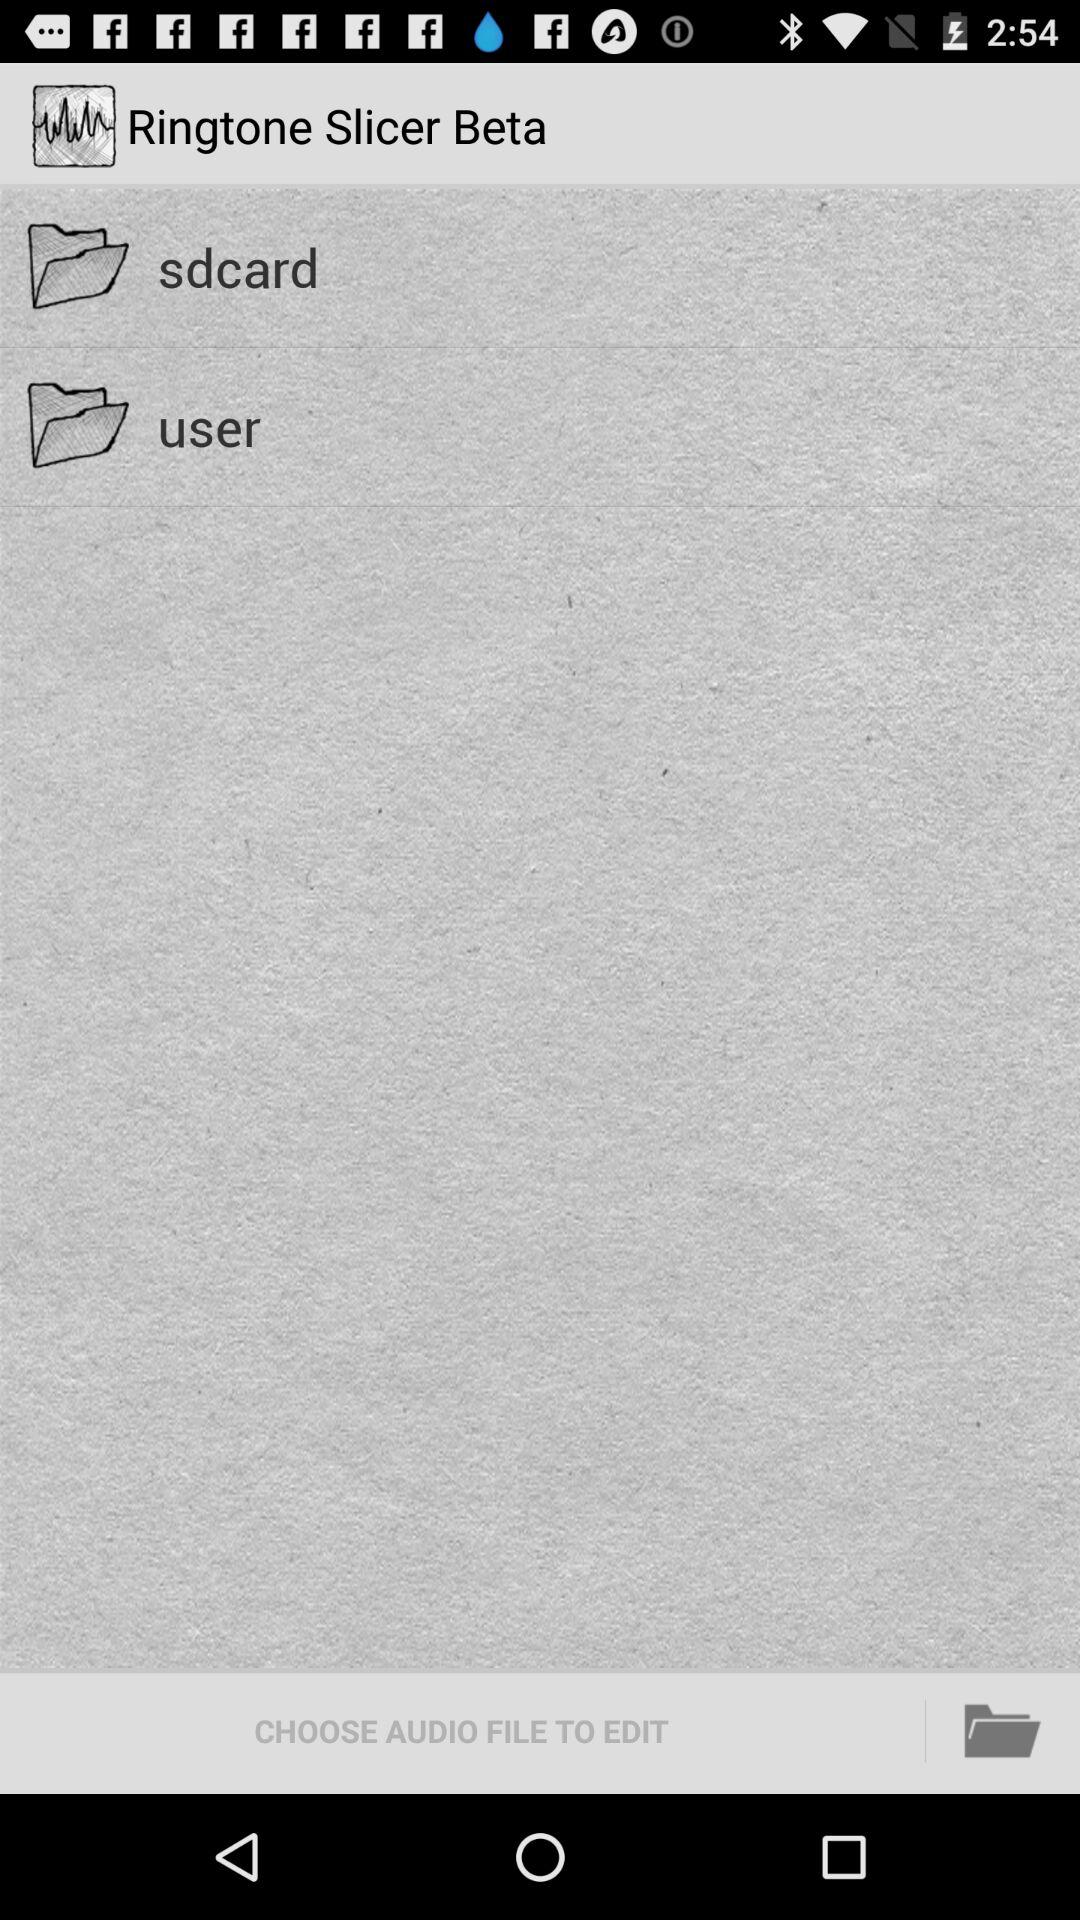What is the app name? The app name is "Ringtone Slicer Beta". 